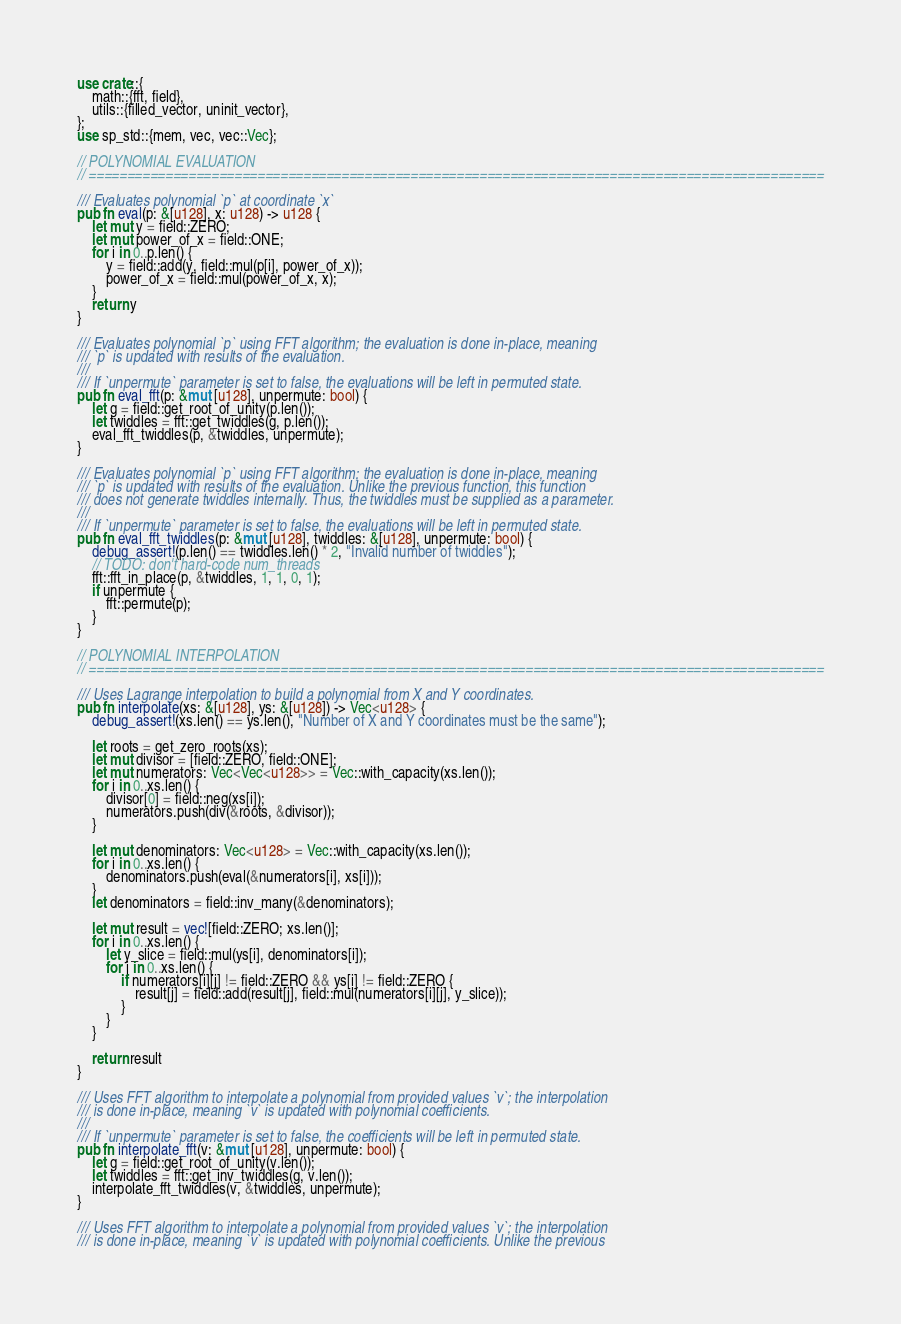Convert code to text. <code><loc_0><loc_0><loc_500><loc_500><_Rust_>use crate::{
	math::{fft, field},
	utils::{filled_vector, uninit_vector},
};
use sp_std::{mem, vec, vec::Vec};

// POLYNOMIAL EVALUATION
// ================================================================================================

/// Evaluates polynomial `p` at coordinate `x`
pub fn eval(p: &[u128], x: u128) -> u128 {
	let mut y = field::ZERO;
	let mut power_of_x = field::ONE;
	for i in 0..p.len() {
		y = field::add(y, field::mul(p[i], power_of_x));
		power_of_x = field::mul(power_of_x, x);
	}
	return y
}

/// Evaluates polynomial `p` using FFT algorithm; the evaluation is done in-place, meaning
/// `p` is updated with results of the evaluation.
///
/// If `unpermute` parameter is set to false, the evaluations will be left in permuted state.
pub fn eval_fft(p: &mut [u128], unpermute: bool) {
	let g = field::get_root_of_unity(p.len());
	let twiddles = fft::get_twiddles(g, p.len());
	eval_fft_twiddles(p, &twiddles, unpermute);
}

/// Evaluates polynomial `p` using FFT algorithm; the evaluation is done in-place, meaning
/// `p` is updated with results of the evaluation. Unlike the previous function, this function
/// does not generate twiddles internally. Thus, the twiddles must be supplied as a parameter.
///
/// If `unpermute` parameter is set to false, the evaluations will be left in permuted state.
pub fn eval_fft_twiddles(p: &mut [u128], twiddles: &[u128], unpermute: bool) {
	debug_assert!(p.len() == twiddles.len() * 2, "Invalid number of twiddles");
	// TODO: don't hard-code num_threads
	fft::fft_in_place(p, &twiddles, 1, 1, 0, 1);
	if unpermute {
		fft::permute(p);
	}
}

// POLYNOMIAL INTERPOLATION
// ================================================================================================

/// Uses Lagrange interpolation to build a polynomial from X and Y coordinates.
pub fn interpolate(xs: &[u128], ys: &[u128]) -> Vec<u128> {
	debug_assert!(xs.len() == ys.len(), "Number of X and Y coordinates must be the same");

	let roots = get_zero_roots(xs);
	let mut divisor = [field::ZERO, field::ONE];
	let mut numerators: Vec<Vec<u128>> = Vec::with_capacity(xs.len());
	for i in 0..xs.len() {
		divisor[0] = field::neg(xs[i]);
		numerators.push(div(&roots, &divisor));
	}

	let mut denominators: Vec<u128> = Vec::with_capacity(xs.len());
	for i in 0..xs.len() {
		denominators.push(eval(&numerators[i], xs[i]));
	}
	let denominators = field::inv_many(&denominators);

	let mut result = vec![field::ZERO; xs.len()];
	for i in 0..xs.len() {
		let y_slice = field::mul(ys[i], denominators[i]);
		for j in 0..xs.len() {
			if numerators[i][j] != field::ZERO && ys[i] != field::ZERO {
				result[j] = field::add(result[j], field::mul(numerators[i][j], y_slice));
			}
		}
	}

	return result
}

/// Uses FFT algorithm to interpolate a polynomial from provided values `v`; the interpolation
/// is done in-place, meaning `v` is updated with polynomial coefficients.
///
/// If `unpermute` parameter is set to false, the coefficients will be left in permuted state.
pub fn interpolate_fft(v: &mut [u128], unpermute: bool) {
	let g = field::get_root_of_unity(v.len());
	let twiddles = fft::get_inv_twiddles(g, v.len());
	interpolate_fft_twiddles(v, &twiddles, unpermute);
}

/// Uses FFT algorithm to interpolate a polynomial from provided values `v`; the interpolation
/// is done in-place, meaning `v` is updated with polynomial coefficients. Unlike the previous</code> 